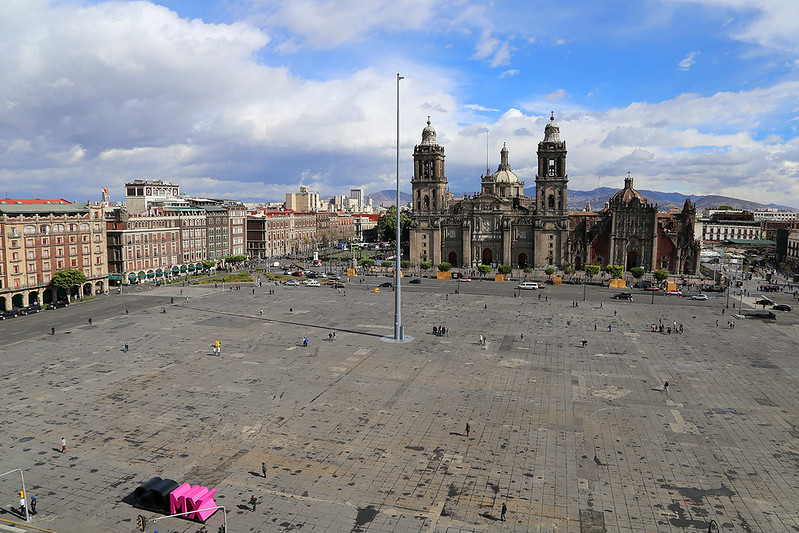Describe a short scenario in the Zócalo during a protest. During a protest in the Zócalo, the atmosphere is charged with energy and determination. The square fills with people holding signs, chanting slogans, and waving banners demanding justice and change. The Metropolitan Cathedral and nearby buildings serve as a historic backdrop to the outcry.

A stage is set up where speakers deliver passionate speeches, amplifying their voices through microphones. The crowd listens intently, their faces a mix of determination and hope. The presence of security personnel is noticeable, maintaining order and ensuring the safety of the demonstrators.

The air is vibrant with the sound of drums and chants, creating a rhythm that resonates through the historic square. As the protest unfolds, the Zócalo stands as a testament to the resilience of the people, echoing with their calls for a better future. 